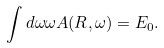<formula> <loc_0><loc_0><loc_500><loc_500>\int d \omega \omega A ( { R } , \omega ) = E _ { 0 } .</formula> 